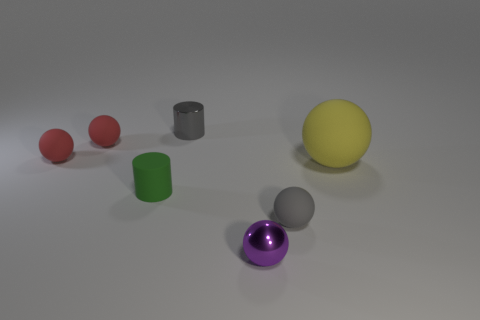Subtract 1 spheres. How many spheres are left? 4 Add 1 big matte spheres. How many objects exist? 8 Subtract all balls. How many objects are left? 2 Add 2 matte cylinders. How many matte cylinders are left? 3 Add 7 big yellow spheres. How many big yellow spheres exist? 8 Subtract 0 blue spheres. How many objects are left? 7 Subtract all yellow objects. Subtract all yellow things. How many objects are left? 5 